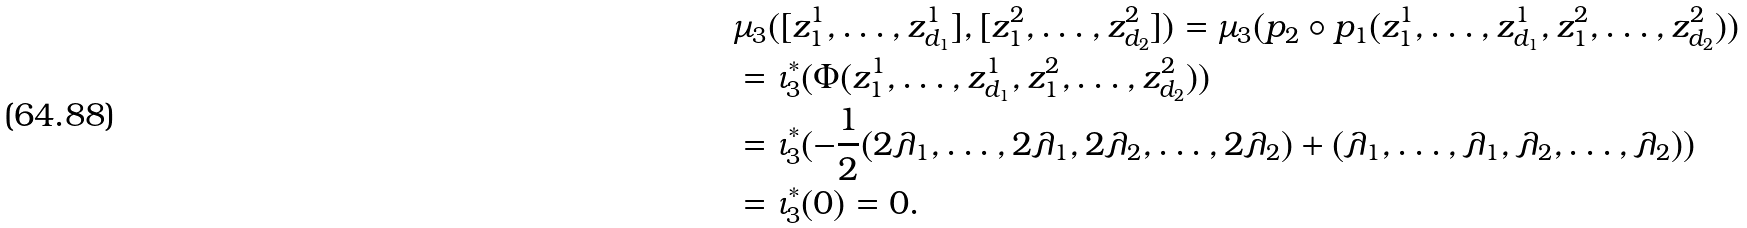<formula> <loc_0><loc_0><loc_500><loc_500>& \mu _ { 3 } ( [ z ^ { 1 } _ { 1 } , \dots , z ^ { 1 } _ { d _ { 1 } } ] , [ z ^ { 2 } _ { 1 } , \dots , z ^ { 2 } _ { d _ { 2 } } ] ) = \mu _ { 3 } ( p _ { 2 } \circ p _ { 1 } ( z ^ { 1 } _ { 1 } , \dots , z ^ { 1 } _ { d _ { 1 } } , z ^ { 2 } _ { 1 } , \dots , z ^ { 2 } _ { d _ { 2 } } ) ) \\ & = \iota _ { 3 } ^ { \ast } ( \Phi ( z ^ { 1 } _ { 1 } , \dots , z ^ { 1 } _ { d _ { 1 } } , z ^ { 2 } _ { 1 } , \dots , z ^ { 2 } _ { d _ { 2 } } ) ) \\ & = \iota _ { 3 } ^ { \ast } ( - \frac { 1 } { 2 } ( 2 \lambda _ { 1 } , \dots , 2 \lambda _ { 1 } , 2 \lambda _ { 2 } , \dots , 2 \lambda _ { 2 } ) + ( \lambda _ { 1 } , \dots , \lambda _ { 1 } , \lambda _ { 2 } , \dots , \lambda _ { 2 } ) ) \\ & = \iota _ { 3 } ^ { \ast } ( 0 ) = 0 .</formula> 